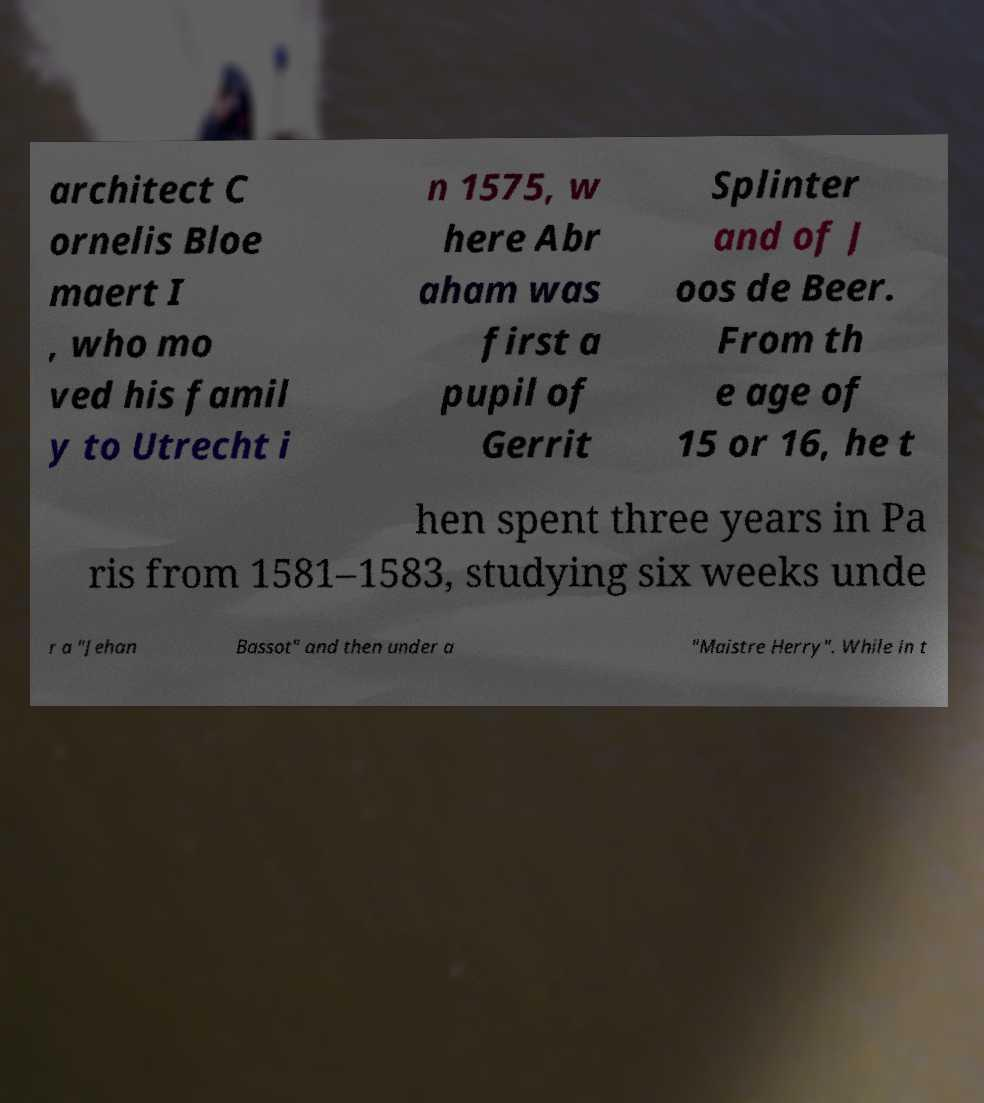For documentation purposes, I need the text within this image transcribed. Could you provide that? architect C ornelis Bloe maert I , who mo ved his famil y to Utrecht i n 1575, w here Abr aham was first a pupil of Gerrit Splinter and of J oos de Beer. From th e age of 15 or 16, he t hen spent three years in Pa ris from 1581–1583, studying six weeks unde r a "Jehan Bassot" and then under a "Maistre Herry". While in t 